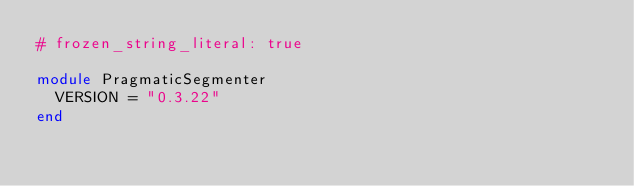<code> <loc_0><loc_0><loc_500><loc_500><_Ruby_># frozen_string_literal: true

module PragmaticSegmenter
  VERSION = "0.3.22"
end
</code> 